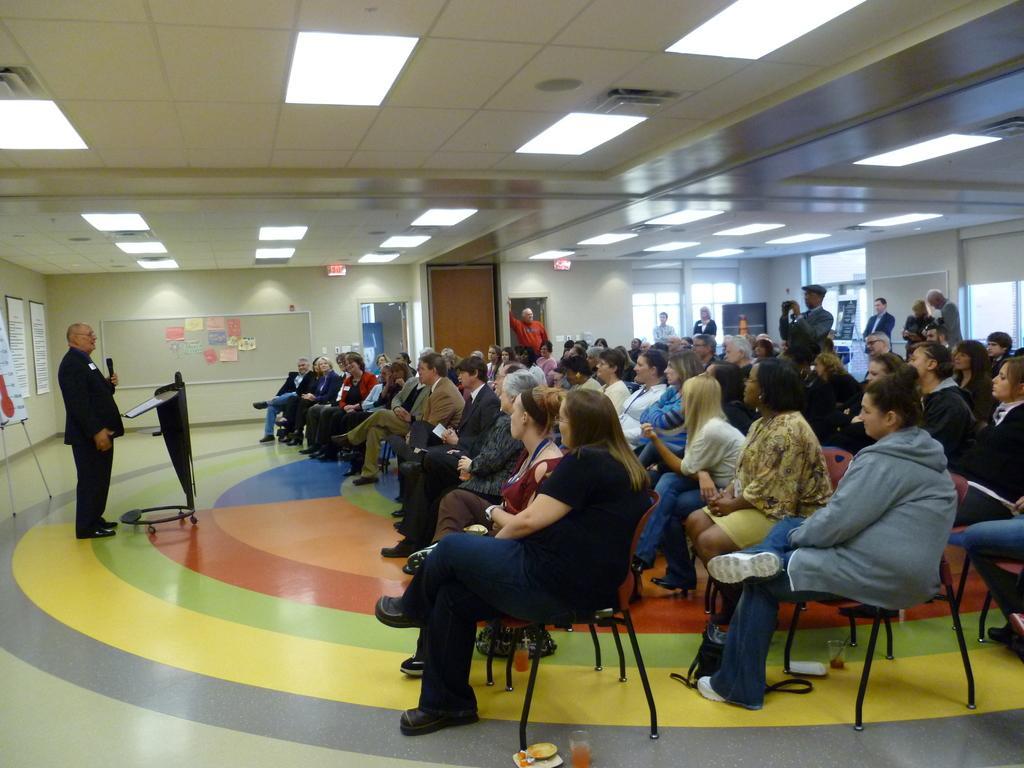Describe this image in one or two sentences. In this image we have a group of people who are sitting on the chair and the person on the left side is holding a mic in his hands and speaking in front of the podium. Behind these people we have a window and white color wall and on the above we have a ceiling and lights, beside these people we have board with papers on it and we have a well design floor. 